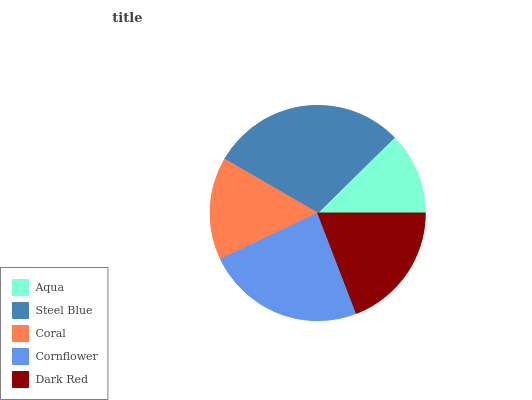Is Aqua the minimum?
Answer yes or no. Yes. Is Steel Blue the maximum?
Answer yes or no. Yes. Is Coral the minimum?
Answer yes or no. No. Is Coral the maximum?
Answer yes or no. No. Is Steel Blue greater than Coral?
Answer yes or no. Yes. Is Coral less than Steel Blue?
Answer yes or no. Yes. Is Coral greater than Steel Blue?
Answer yes or no. No. Is Steel Blue less than Coral?
Answer yes or no. No. Is Dark Red the high median?
Answer yes or no. Yes. Is Dark Red the low median?
Answer yes or no. Yes. Is Aqua the high median?
Answer yes or no. No. Is Aqua the low median?
Answer yes or no. No. 